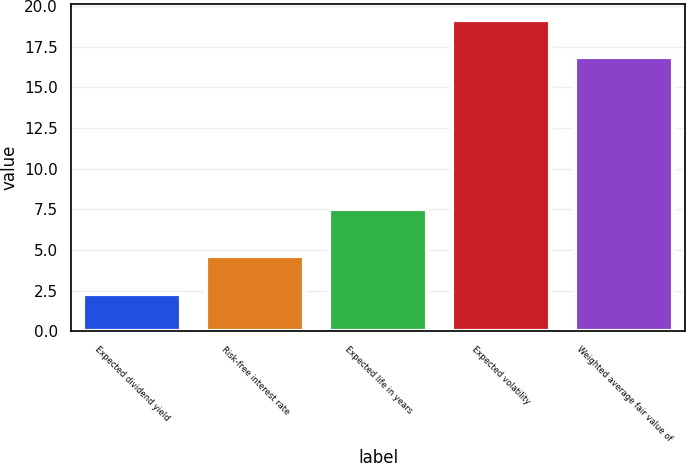Convert chart. <chart><loc_0><loc_0><loc_500><loc_500><bar_chart><fcel>Expected dividend yield<fcel>Risk-free interest rate<fcel>Expected life in years<fcel>Expected volatility<fcel>Weighted average fair value of<nl><fcel>2.28<fcel>4.65<fcel>7.5<fcel>19.15<fcel>16.85<nl></chart> 